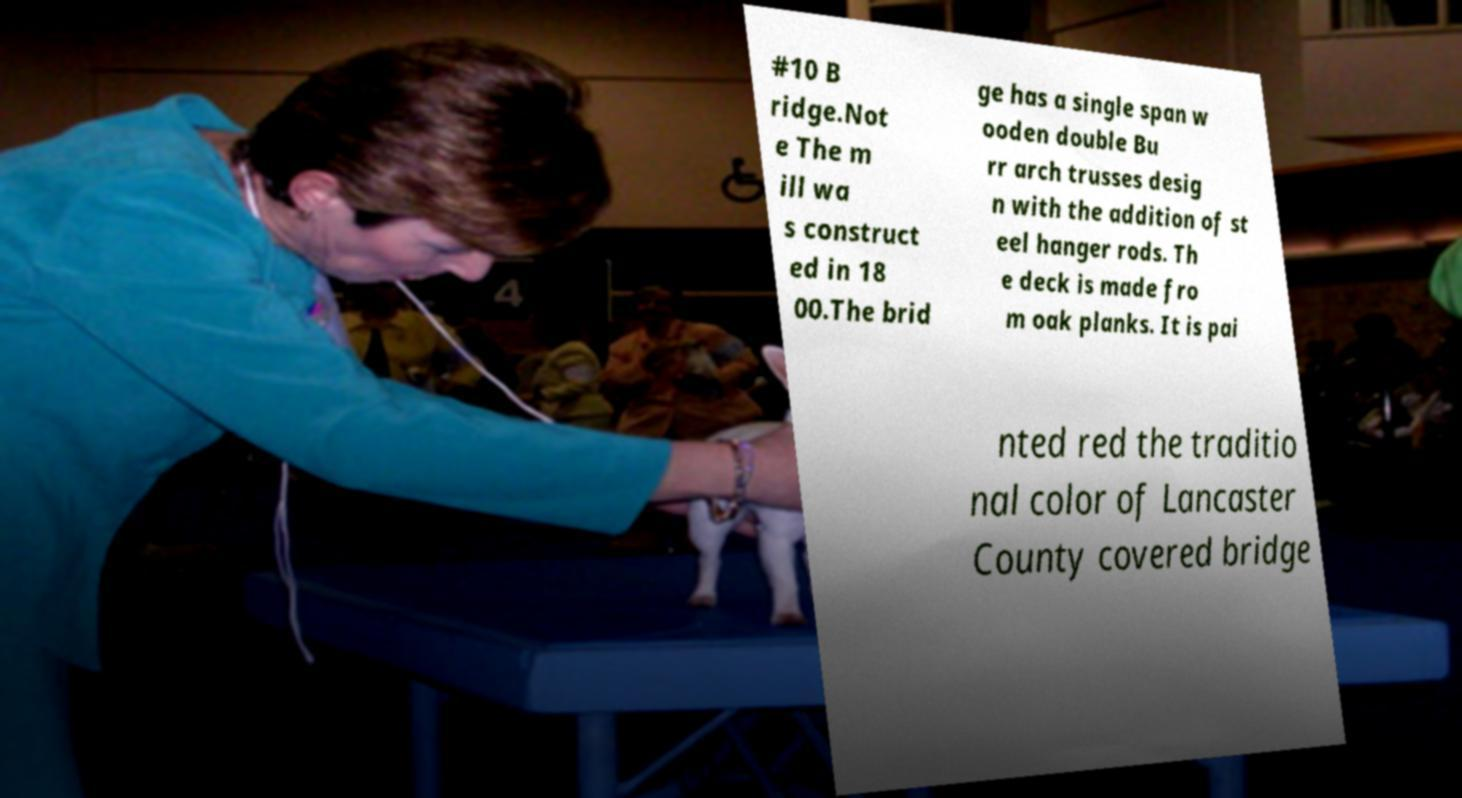Can you accurately transcribe the text from the provided image for me? #10 B ridge.Not e The m ill wa s construct ed in 18 00.The brid ge has a single span w ooden double Bu rr arch trusses desig n with the addition of st eel hanger rods. Th e deck is made fro m oak planks. It is pai nted red the traditio nal color of Lancaster County covered bridge 